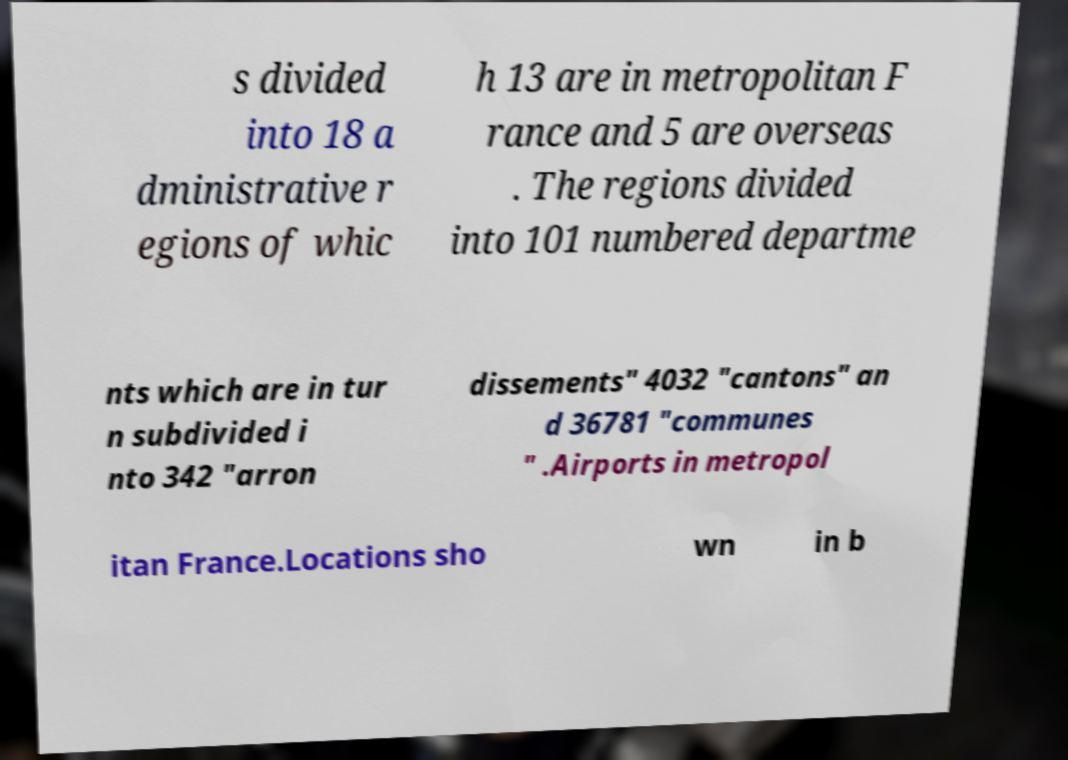There's text embedded in this image that I need extracted. Can you transcribe it verbatim? s divided into 18 a dministrative r egions of whic h 13 are in metropolitan F rance and 5 are overseas . The regions divided into 101 numbered departme nts which are in tur n subdivided i nto 342 "arron dissements" 4032 "cantons" an d 36781 "communes " .Airports in metropol itan France.Locations sho wn in b 